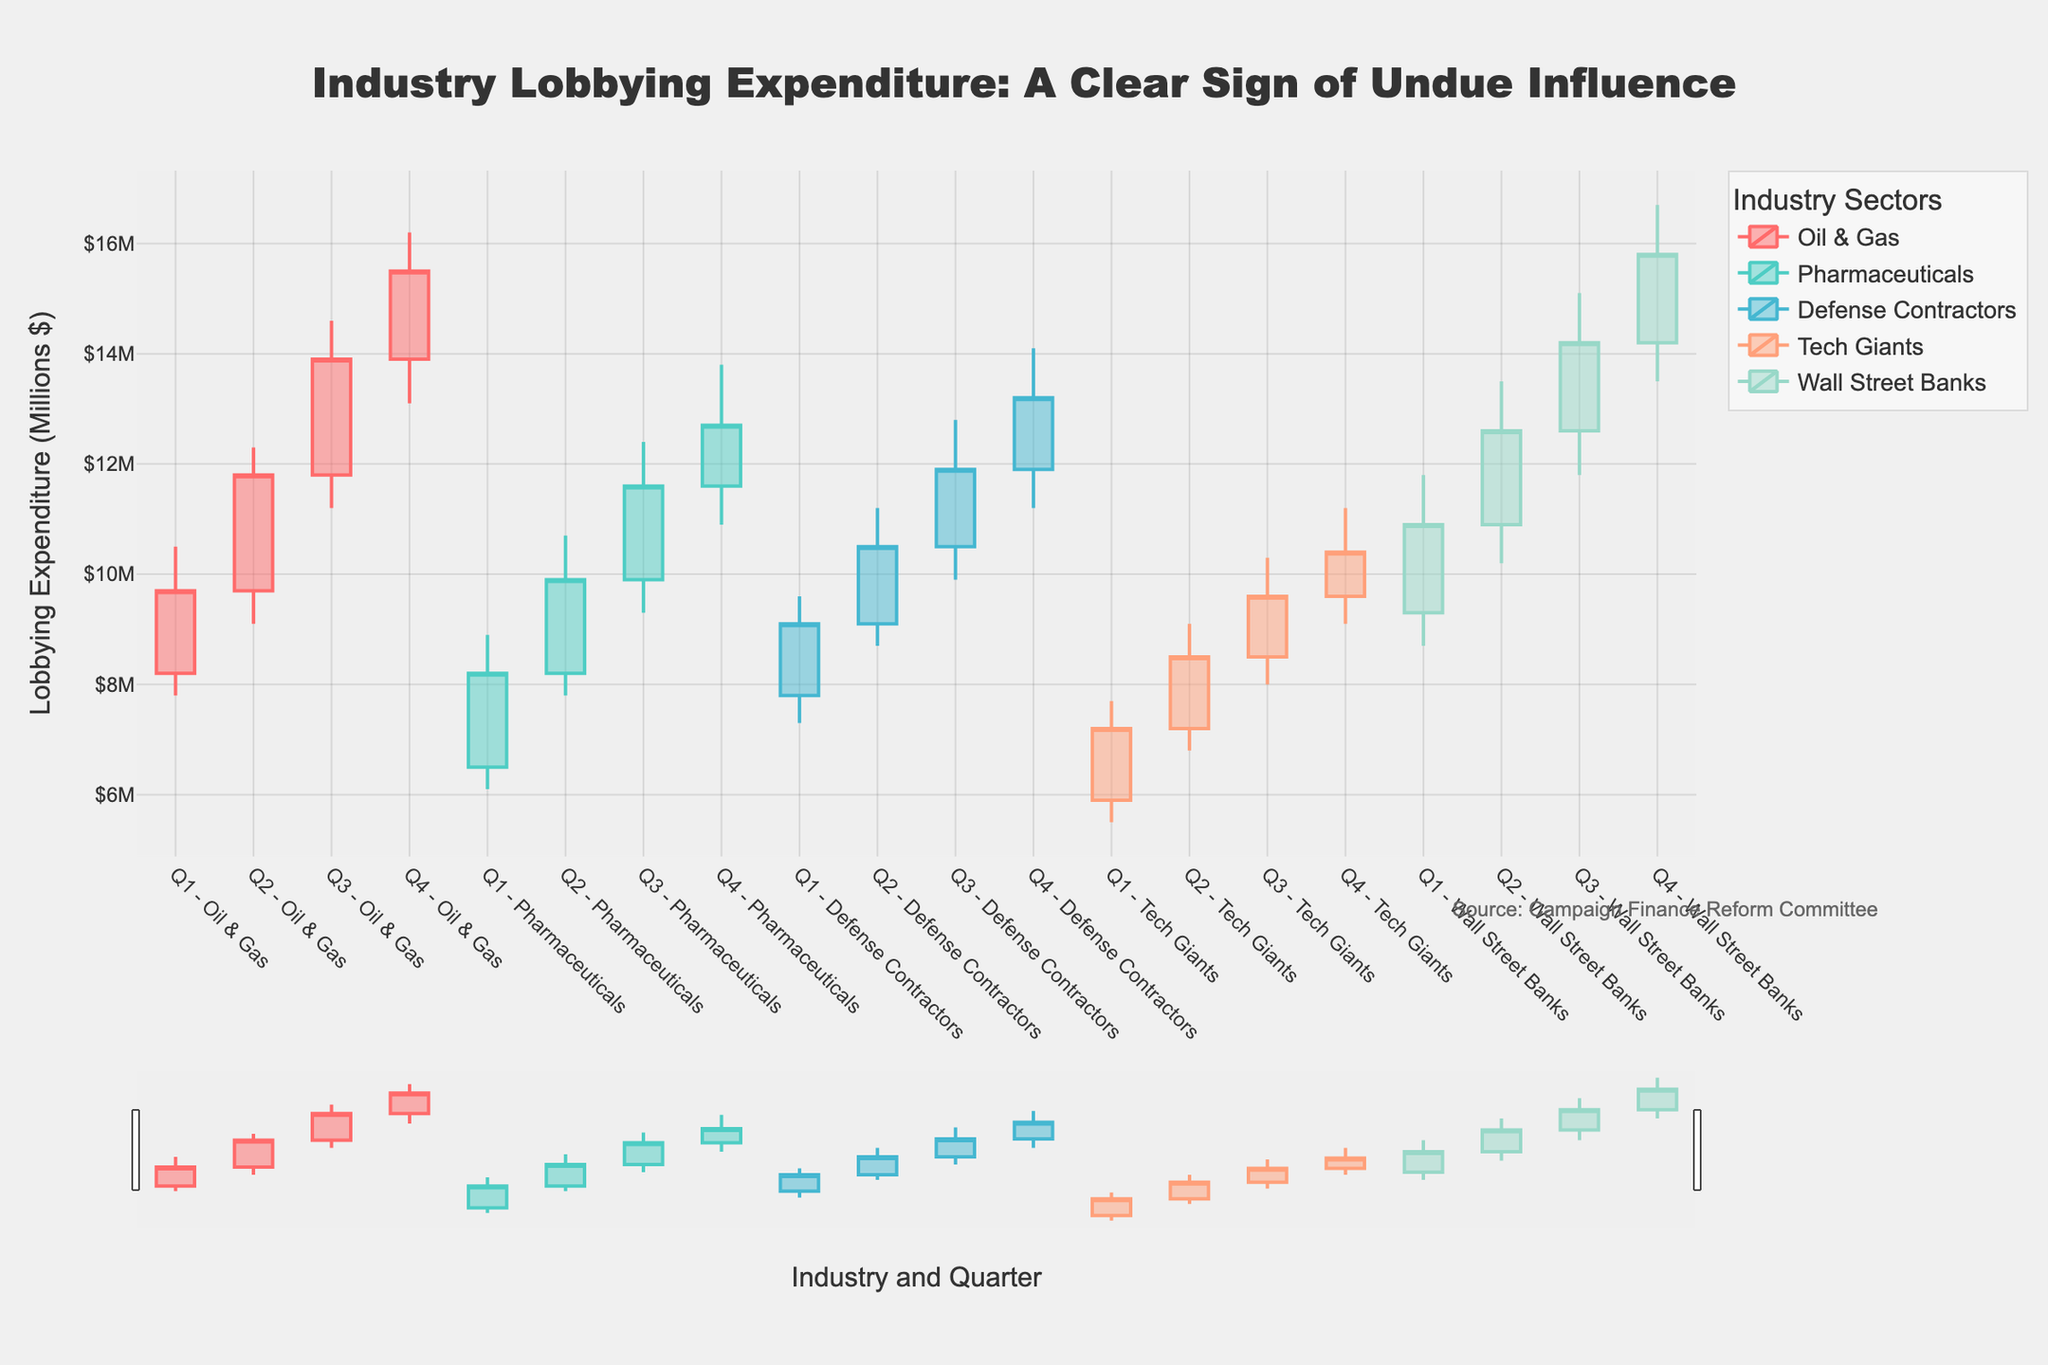Who has the highest closing lobbying expenditure in Q4? In Q4, check each industry's closing values: Oil & Gas (15.5), Pharmaceuticals (12.7), Defense Contractors (13.2), Tech Giants (10.4), and Wall Street Banks (15.8). Wall Street Banks have the highest closing value at 15.8 million.
Answer: Wall Street Banks How did the Oil & Gas lobbying expenditure change from Q1 to Q2? In Q1, Oil & Gas closes at 9.7 million, and it opens Q2 at 9.7 million, ending Q2 at 11.8 million. The expenditure increased by 2.1 million (11.8 - 9.7).
Answer: Increased by 2.1 million Among the sectors, which one had the most significant increase in its high value from Q2 to Q3? From Q2 to Q3, subtract each sector's Q2_high from Q3_high: Oil & Gas (14.6-12.3=2.3), Pharmaceuticals (12.4-10.7=1.7), Defense Contractors (12.8-11.2=1.6), Tech Giants (10.3-9.1=1.2), Wall Street Banks (15.1-13.5=1.6). The Oil & Gas sector had the most significant increase of 2.3 million.
Answer: Oil & Gas What was the greatest low value observed for any sector across all quarters? Check the low values for each sector across all quarters: Oil & Gas (7.8), Pharmaceuticals (6.1), Defense Contractors (7.3), Tech Giants (5.5), Wall Street Banks (8.7). The greatest low value is for Wall Street Banks at 8.7 million.
Answer: Wall Street Banks, 8.7 million Which sector experienced the least variation (difference between high and low) in Q3? Calculate the high-low for each sector in Q3: Oil & Gas (14.6-11.2=3.4), Pharmaceuticals (12.4-9.3=3.1), Defense Contractors (12.8-9.9=2.9), Tech Giants (10.3-8.0=2.3), Wall Street Banks (15.1-11.8=3.3). Tech Giants had the least variation of 2.3 million.
Answer: Tech Giants Did any sector have a closing value higher than 12 million in Q2? Check the Q2 closing values: Oil & Gas (11.8), Pharmaceuticals (9.9), Defense Contractors (10.5), Tech Giants (8.5), Wall Street Banks (12.6). Wall Street Banks is the only sector with a closing value higher than 12 million in Q2.
Answer: Yes, Wall Street Banks Which sector started Q4 with an opening value higher than 11 million? Check the Q4 opening values: Oil & Gas (13.9), Pharmaceuticals (11.6), Defense Contractors (11.9), Tech Giants (9.6), Wall Street Banks (14.2). Oil & Gas, Pharmaceuticals, Defense Contractors, and Wall Street Banks all opened Q4 over 11 million.
Answer: Oil & Gas, Pharmaceuticals, Defense Contractors, Wall Street Banks Among all quarters for the Pharmaceuticals sector, which quarter had the lowest closing value and what was it? Check the closing values for Pharmaceuticals in each quarter: Q1 (8.2), Q2 (9.9), Q3 (11.6), Q4 (12.7). The lowest closing value was in Q1 at 8.2 million.
Answer: Q1, 8.2 million What is the difference between the highest closing value and the lowest closing value across all sectors and quarters? Identify the highest and lowest closing values: Highest - Wall Street Banks Q4 (15.8), Lowest - Tech Giants Q1 (7.2). The difference is 15.8 - 7.2 = 8.6 million.
Answer: 8.6 million 